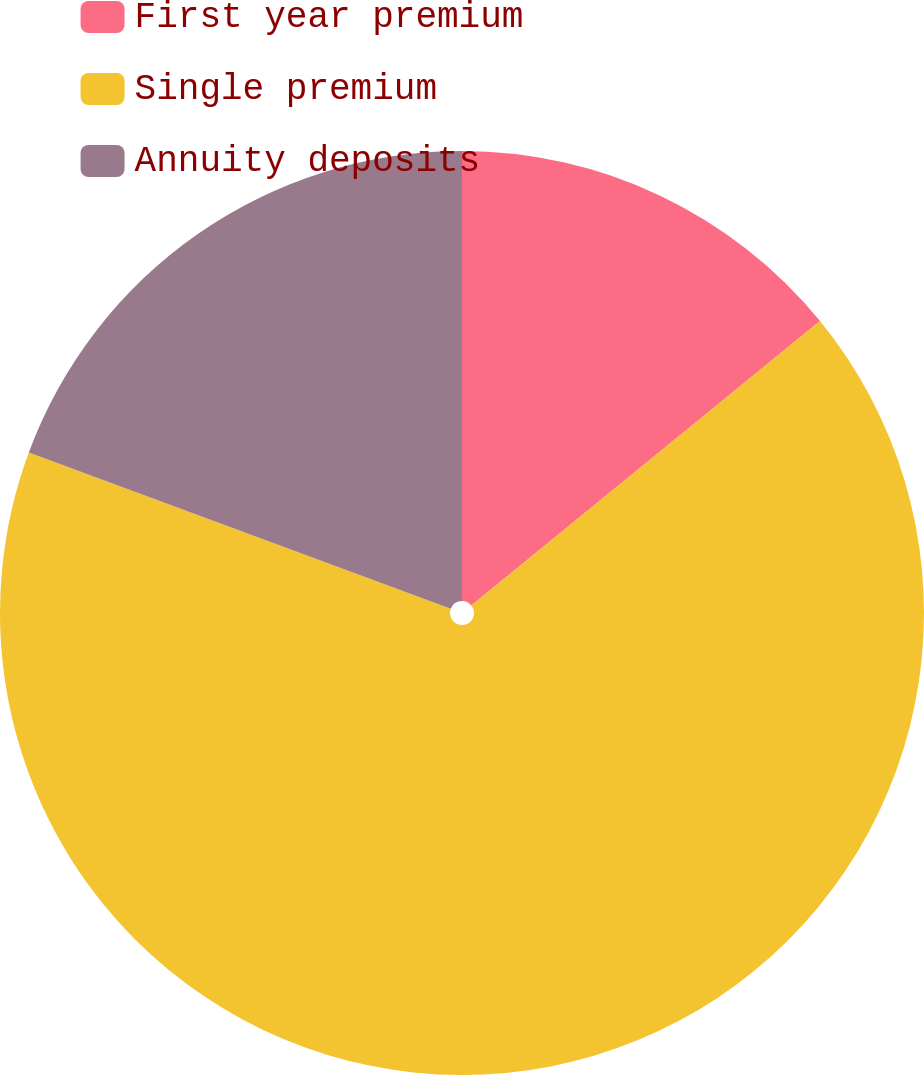Convert chart to OTSL. <chart><loc_0><loc_0><loc_500><loc_500><pie_chart><fcel>First year premium<fcel>Single premium<fcel>Annuity deposits<nl><fcel>14.11%<fcel>66.53%<fcel>19.35%<nl></chart> 